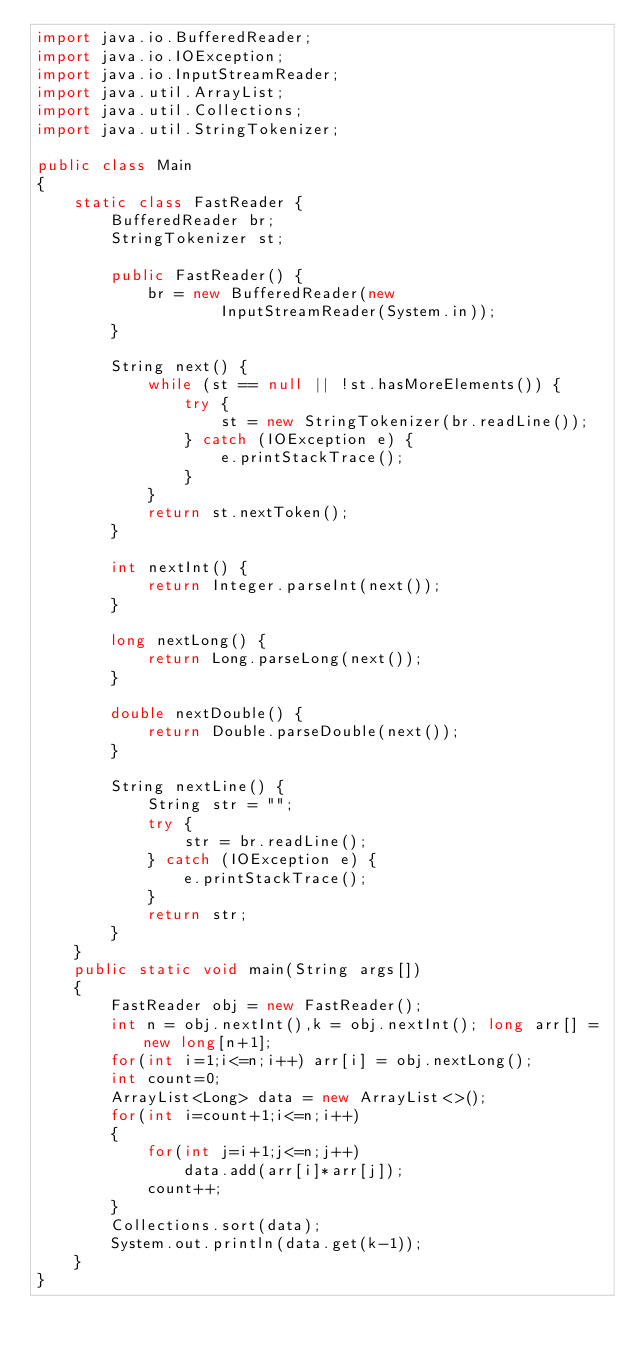<code> <loc_0><loc_0><loc_500><loc_500><_Java_>import java.io.BufferedReader;
import java.io.IOException;
import java.io.InputStreamReader;
import java.util.ArrayList;
import java.util.Collections;
import java.util.StringTokenizer;

public class Main
{
    static class FastReader {
        BufferedReader br;
        StringTokenizer st;

        public FastReader() {
            br = new BufferedReader(new
                    InputStreamReader(System.in));
        }

        String next() {
            while (st == null || !st.hasMoreElements()) {
                try {
                    st = new StringTokenizer(br.readLine());
                } catch (IOException e) {
                    e.printStackTrace();
                }
            }
            return st.nextToken();
        }

        int nextInt() {
            return Integer.parseInt(next());
        }

        long nextLong() {
            return Long.parseLong(next());
        }

        double nextDouble() {
            return Double.parseDouble(next());
        }

        String nextLine() {
            String str = "";
            try {
                str = br.readLine();
            } catch (IOException e) {
                e.printStackTrace();
            }
            return str;
        }
    }
    public static void main(String args[])
    {
        FastReader obj = new FastReader();
        int n = obj.nextInt(),k = obj.nextInt(); long arr[] = new long[n+1];
        for(int i=1;i<=n;i++) arr[i] = obj.nextLong();
        int count=0;
        ArrayList<Long> data = new ArrayList<>();
        for(int i=count+1;i<=n;i++)
        {
            for(int j=i+1;j<=n;j++)
                data.add(arr[i]*arr[j]);
            count++;
        }
        Collections.sort(data);
        System.out.println(data.get(k-1));
    }
}

</code> 